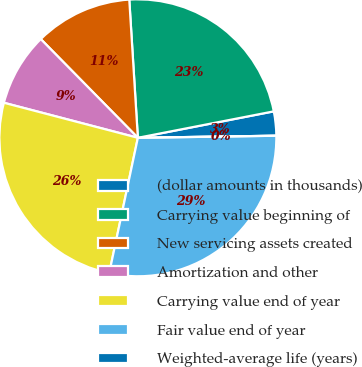Convert chart. <chart><loc_0><loc_0><loc_500><loc_500><pie_chart><fcel>(dollar amounts in thousands)<fcel>Carrying value beginning of<fcel>New servicing assets created<fcel>Amortization and other<fcel>Carrying value end of year<fcel>Fair value end of year<fcel>Weighted-average life (years)<nl><fcel>2.82%<fcel>22.93%<fcel>11.38%<fcel>8.56%<fcel>25.75%<fcel>28.56%<fcel>0.0%<nl></chart> 